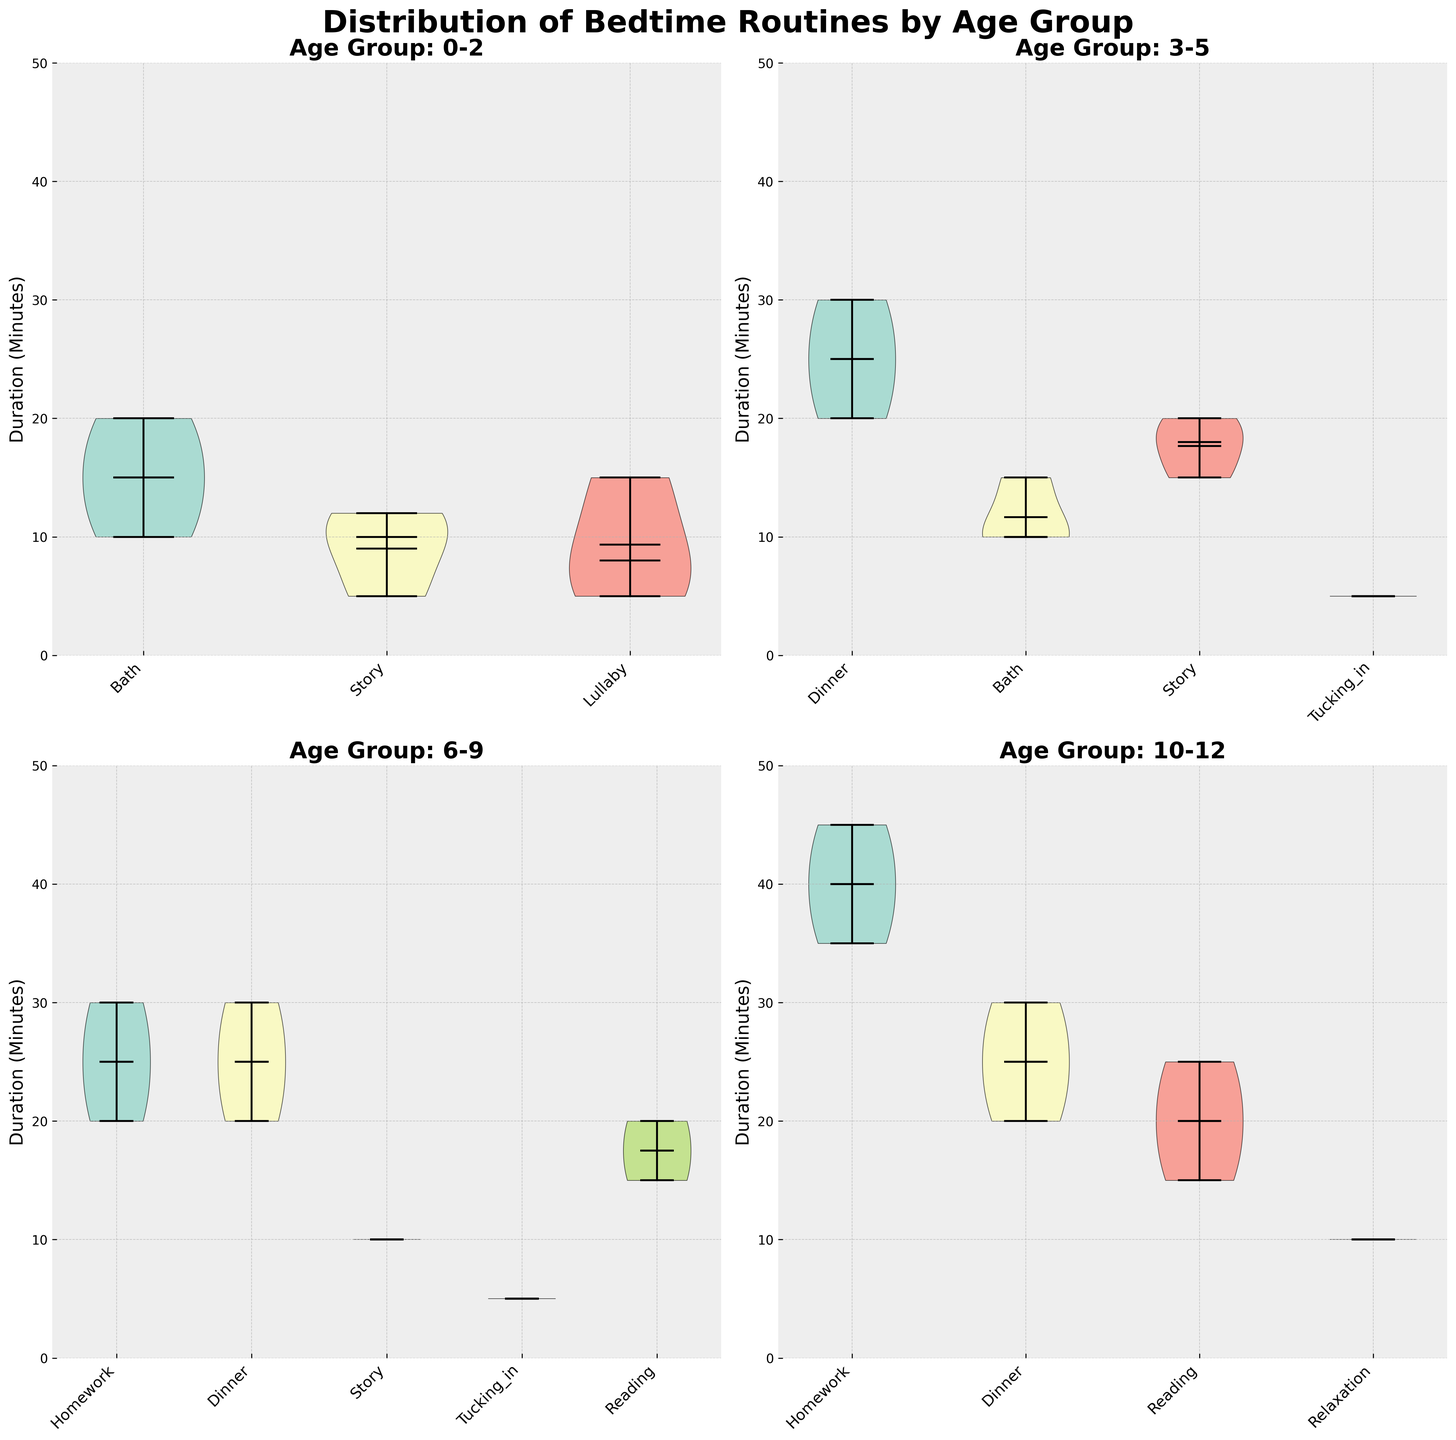What's the title of the figure? The title is found at the top of the figure. It provides a summary of what the entire plot represents.
Answer: Distribution of Bedtime Routines by Age Group What are the four age groups represented in the subplots? Each subplot is a different panel in the figure that displays data for a specific age group. You can identify them by looking at the titles of each subplot.
Answer: 0-2, 3-5, 6-9, 10-12 Which activity in the 0-2 age group has the shortest median duration? To figure this out, check the location of the median indicator within each violin plot in the 0-2 age group subplot.
Answer: Lullaby Comparing the 3-5 and 6-9 age groups, which one has a higher median duration of the Dinner activity? Identify the median line in the "Dinner" violin plots for both age groups and compare their positions vertically.
Answer: 6-9 For the 10-12 age group, what is the range of durations for Homework? Look for the Homework violin plot in the 10-12 age group and identify the highest and lowest points. The range is the difference between these values.
Answer: 40 - 45 minutes Which age group demonstrates the most variability in the duration of Story activities? Assess the width and spread of the violin plot for Story activities in each age group. The broader and more spread out the plot, the greater the variability.
Answer: 0-2 Are there any activities that are unique to only one age group? If so, which ones? Evaluate the activities listed in each subplot and note any that appear in only one age group.
Answer: Yes, Bath in 0-2; Tucking_in in 3-5; Reading and Relaxation in 10-12 Between the age groups 3-5 and 6-9, which has a greater mean duration for the activity Story? Determine the mean line in the Story violin plots of the respective age groups and compare their positions.
Answer: 3-5 In the age group 10-12, which activity has the highest mean duration? Identify the mean line in each activity's violin plot within the 10-12 age group. The activity with the highest mean line is the answer.
Answer: Homework 